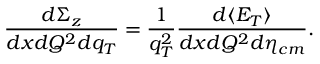<formula> <loc_0><loc_0><loc_500><loc_500>\frac { d \Sigma _ { z } } { d x d Q ^ { 2 } d q _ { T } } = \frac { 1 } { q _ { T } ^ { 2 } } \frac { d \langle E _ { T } \rangle } { d x d Q ^ { 2 } d \eta _ { c m } } .</formula> 